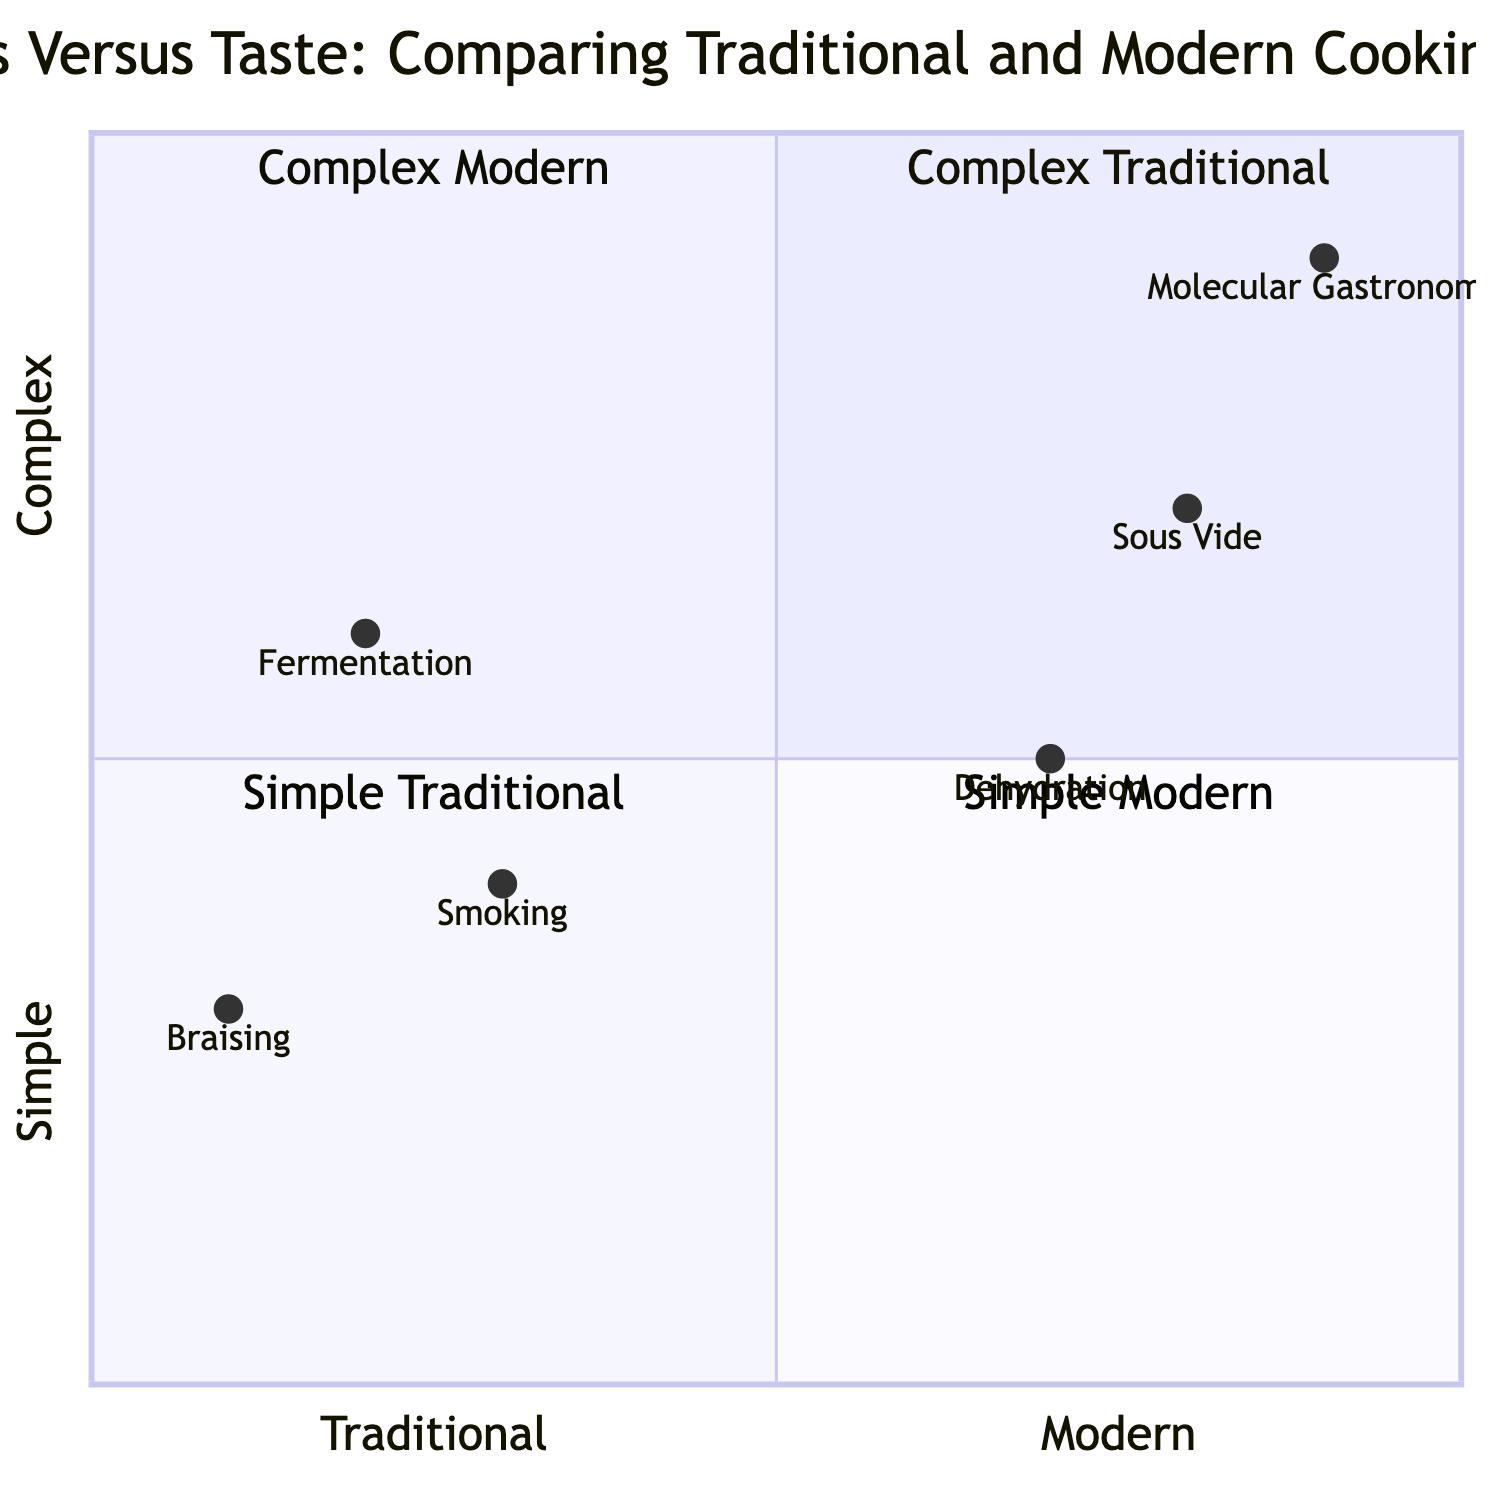What is the position of "Sous Vide" in the diagram? "Sous Vide" is located in Quadrant 4, with coordinates [0.8, 0.7], indicating that it is a modern cooking technique and considered complex in terms of taste.
Answer: Quadrant 4 Which cooking technique is shown in the top left quadrant? The top left quadrant corresponds to Complex Traditional techniques. Based on the given data and coordinates, there are no techniques in that quadrant.
Answer: None How many techniques are categorized as "Traditional"? There are three techniques categorized as Traditional: Fermentation, Smoking, and Braising.
Answer: Three Which modern technique has the highest complexity in the diagram? From the coordinates, "Molecular Gastronomy" has the highest complexity with a value of 0.9 on the y-axis, placing it in Quadrant 2.
Answer: Molecular Gastronomy What is the complexity value of "Braising"? "Braising" has a complexity value of 0.3, located in the Simple Traditional quadrant.
Answer: 0.3 Which technique combines both high complexity and modern classification? "Molecular Gastronomy" has the highest complexity value of 0.9 while being categorized as a modern technique.
Answer: Molecular Gastronomy Which traditional technique is located closest to the vertical axis? "Braising" is positioned the closest to the vertical axis with a value of 0.1, indicating it is a simple technique.
Answer: Braising What is the complexity comparison between "Smoking" and "Fermentation"? "Smoking" has a complexity of 0.4 while "Fermentation" has a higher complexity of 0.6, meaning Fermentation is considered more complex.
Answer: Fermentation Which modern technique is adjacent to "Sous Vide" in terms of complexity? "Dehydration" is adjacent to "Sous Vide" with a complexity value of 0.5, making it simpler than Sous Vide.
Answer: Dehydration 